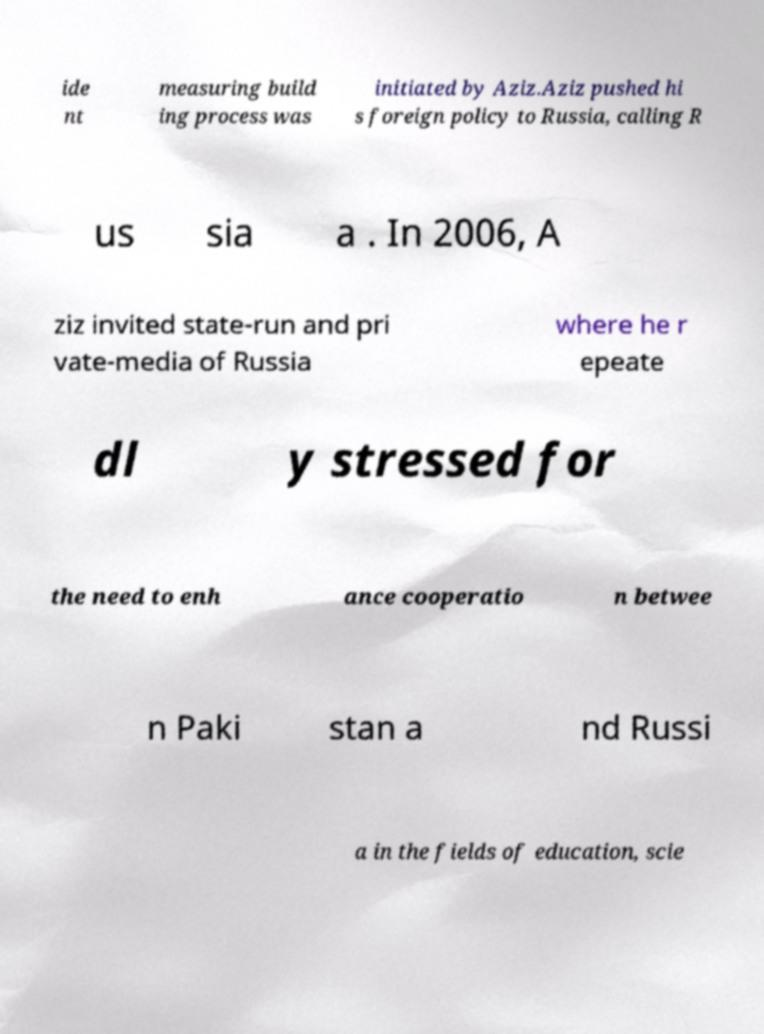Could you extract and type out the text from this image? ide nt measuring build ing process was initiated by Aziz.Aziz pushed hi s foreign policy to Russia, calling R us sia a . In 2006, A ziz invited state-run and pri vate-media of Russia where he r epeate dl y stressed for the need to enh ance cooperatio n betwee n Paki stan a nd Russi a in the fields of education, scie 